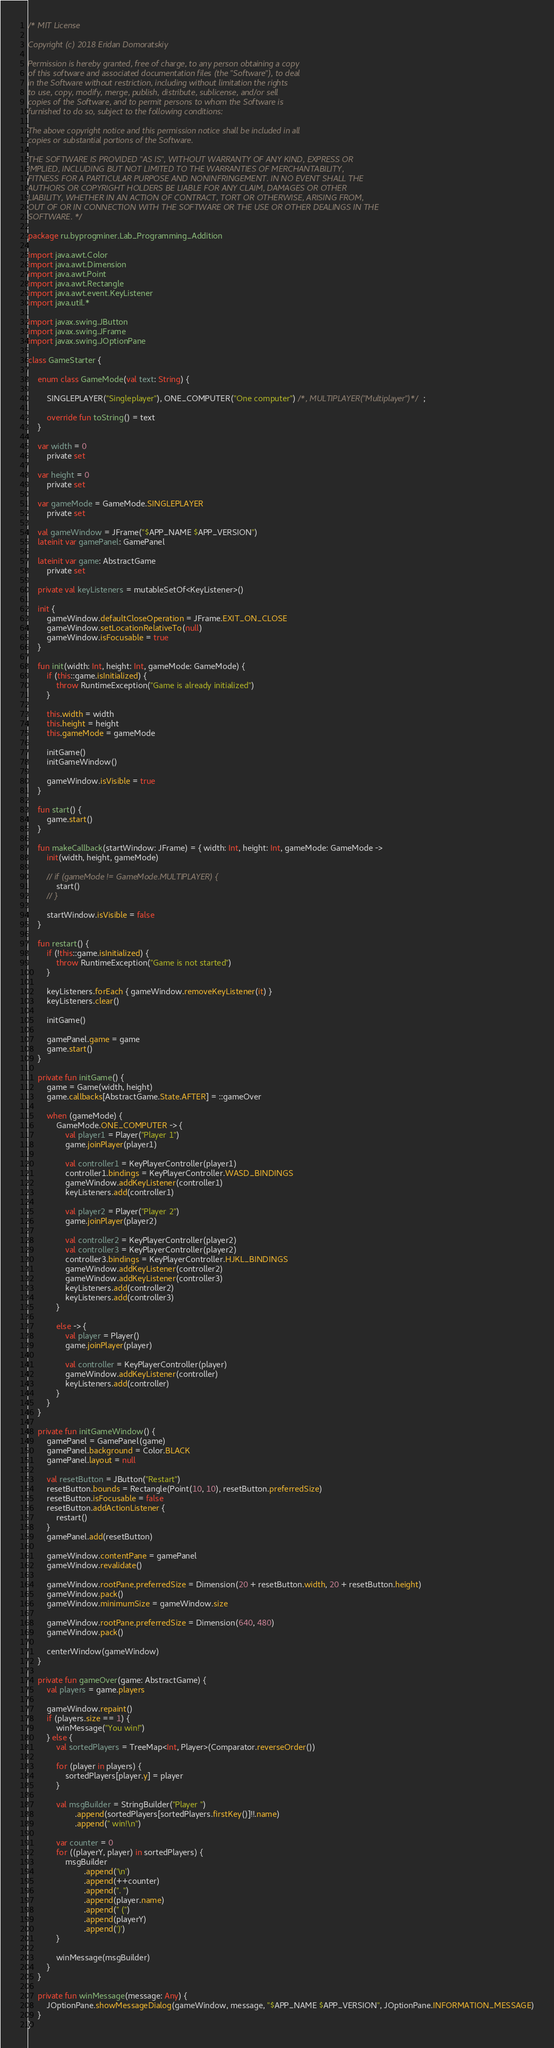Convert code to text. <code><loc_0><loc_0><loc_500><loc_500><_Kotlin_>/* MIT License

Copyright (c) 2018 Eridan Domoratskiy

Permission is hereby granted, free of charge, to any person obtaining a copy
of this software and associated documentation files (the "Software"), to deal
in the Software without restriction, including without limitation the rights
to use, copy, modify, merge, publish, distribute, sublicense, and/or sell
copies of the Software, and to permit persons to whom the Software is
furnished to do so, subject to the following conditions:

The above copyright notice and this permission notice shall be included in all
copies or substantial portions of the Software.

THE SOFTWARE IS PROVIDED "AS IS", WITHOUT WARRANTY OF ANY KIND, EXPRESS OR
IMPLIED, INCLUDING BUT NOT LIMITED TO THE WARRANTIES OF MERCHANTABILITY,
FITNESS FOR A PARTICULAR PURPOSE AND NONINFRINGEMENT. IN NO EVENT SHALL THE
AUTHORS OR COPYRIGHT HOLDERS BE LIABLE FOR ANY CLAIM, DAMAGES OR OTHER
LIABILITY, WHETHER IN AN ACTION OF CONTRACT, TORT OR OTHERWISE, ARISING FROM,
OUT OF OR IN CONNECTION WITH THE SOFTWARE OR THE USE OR OTHER DEALINGS IN THE
SOFTWARE. */

package ru.byprogminer.Lab_Programming_Addition

import java.awt.Color
import java.awt.Dimension
import java.awt.Point
import java.awt.Rectangle
import java.awt.event.KeyListener
import java.util.*

import javax.swing.JButton
import javax.swing.JFrame
import javax.swing.JOptionPane

class GameStarter {

    enum class GameMode(val text: String) {

        SINGLEPLAYER("Singleplayer"), ONE_COMPUTER("One computer") /*, MULTIPLAYER("Multiplayer")*/;

        override fun toString() = text
    }

    var width = 0
        private set

    var height = 0
        private set

    var gameMode = GameMode.SINGLEPLAYER
        private set

    val gameWindow = JFrame("$APP_NAME $APP_VERSION")
    lateinit var gamePanel: GamePanel

    lateinit var game: AbstractGame
        private set

    private val keyListeners = mutableSetOf<KeyListener>()

    init {
        gameWindow.defaultCloseOperation = JFrame.EXIT_ON_CLOSE
        gameWindow.setLocationRelativeTo(null)
        gameWindow.isFocusable = true
    }

    fun init(width: Int, height: Int, gameMode: GameMode) {
        if (this::game.isInitialized) {
            throw RuntimeException("Game is already initialized")
        }

        this.width = width
        this.height = height
        this.gameMode = gameMode

        initGame()
        initGameWindow()

        gameWindow.isVisible = true
    }

    fun start() {
        game.start()
    }

    fun makeCallback(startWindow: JFrame) = { width: Int, height: Int, gameMode: GameMode ->
        init(width, height, gameMode)

        // if (gameMode != GameMode.MULTIPLAYER) {
            start()
        // }

        startWindow.isVisible = false
    }

    fun restart() {
        if (!this::game.isInitialized) {
            throw RuntimeException("Game is not started")
        }

        keyListeners.forEach { gameWindow.removeKeyListener(it) }
        keyListeners.clear()

        initGame()

        gamePanel.game = game
        game.start()
    }

    private fun initGame() {
        game = Game(width, height)
        game.callbacks[AbstractGame.State.AFTER] = ::gameOver

        when (gameMode) {
            GameMode.ONE_COMPUTER -> {
                val player1 = Player("Player 1")
                game.joinPlayer(player1)

                val controller1 = KeyPlayerController(player1)
                controller1.bindings = KeyPlayerController.WASD_BINDINGS
                gameWindow.addKeyListener(controller1)
                keyListeners.add(controller1)

                val player2 = Player("Player 2")
                game.joinPlayer(player2)

                val controller2 = KeyPlayerController(player2)
                val controller3 = KeyPlayerController(player2)
                controller3.bindings = KeyPlayerController.HJKL_BINDINGS
                gameWindow.addKeyListener(controller2)
                gameWindow.addKeyListener(controller3)
                keyListeners.add(controller2)
                keyListeners.add(controller3)
            }

            else -> {
                val player = Player()
                game.joinPlayer(player)

                val controller = KeyPlayerController(player)
                gameWindow.addKeyListener(controller)
                keyListeners.add(controller)
            }
        }
    }

    private fun initGameWindow() {
        gamePanel = GamePanel(game)
        gamePanel.background = Color.BLACK
        gamePanel.layout = null

        val resetButton = JButton("Restart")
        resetButton.bounds = Rectangle(Point(10, 10), resetButton.preferredSize)
        resetButton.isFocusable = false
        resetButton.addActionListener {
            restart()
        }
        gamePanel.add(resetButton)

        gameWindow.contentPane = gamePanel
        gameWindow.revalidate()

        gameWindow.rootPane.preferredSize = Dimension(20 + resetButton.width, 20 + resetButton.height)
        gameWindow.pack()
        gameWindow.minimumSize = gameWindow.size

        gameWindow.rootPane.preferredSize = Dimension(640, 480)
        gameWindow.pack()

        centerWindow(gameWindow)
    }

    private fun gameOver(game: AbstractGame) {
        val players = game.players

        gameWindow.repaint()
        if (players.size == 1) {
            winMessage("You win!")
        } else {
            val sortedPlayers = TreeMap<Int, Player>(Comparator.reverseOrder())

            for (player in players) {
                sortedPlayers[player.y] = player
            }

            val msgBuilder = StringBuilder("Player ")
                    .append(sortedPlayers[sortedPlayers.firstKey()]!!.name)
                    .append(" win!\n")

            var counter = 0
            for ((playerY, player) in sortedPlayers) {
                msgBuilder
                        .append('\n')
                        .append(++counter)
                        .append(". ")
                        .append(player.name)
                        .append(" (")
                        .append(playerY)
                        .append(')')
            }

            winMessage(msgBuilder)
        }
    }

    private fun winMessage(message: Any) {
        JOptionPane.showMessageDialog(gameWindow, message, "$APP_NAME $APP_VERSION", JOptionPane.INFORMATION_MESSAGE)
    }
}
</code> 